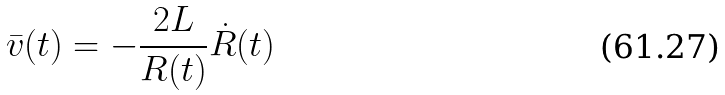<formula> <loc_0><loc_0><loc_500><loc_500>\bar { v } ( t ) = - \frac { 2 L } { R ( t ) } \dot { R } ( t )</formula> 